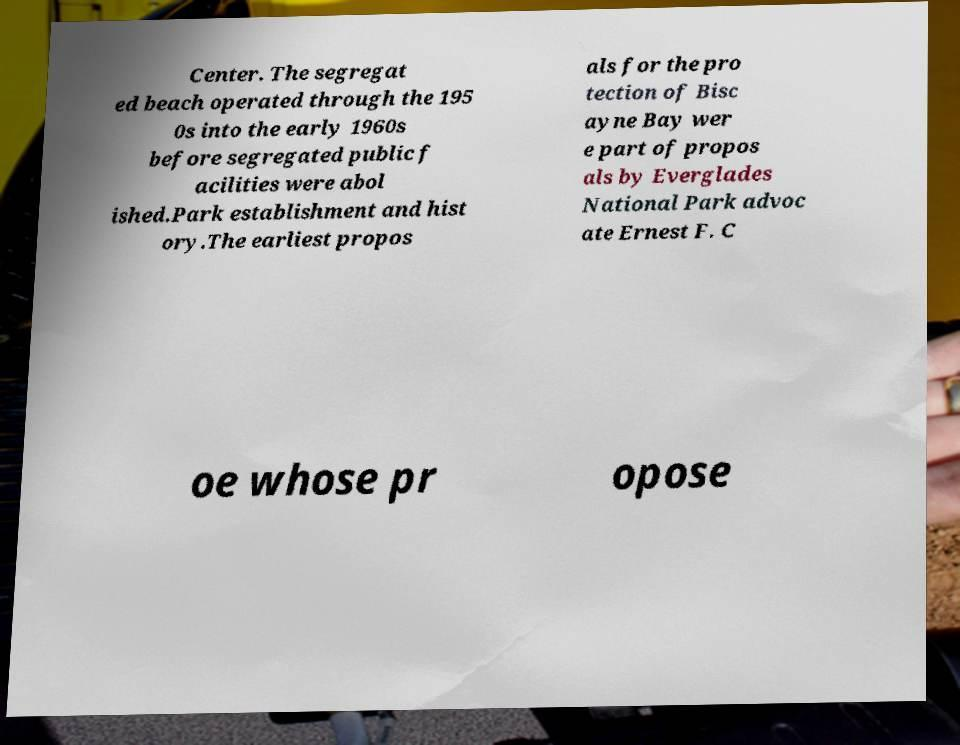Please read and relay the text visible in this image. What does it say? Center. The segregat ed beach operated through the 195 0s into the early 1960s before segregated public f acilities were abol ished.Park establishment and hist ory.The earliest propos als for the pro tection of Bisc ayne Bay wer e part of propos als by Everglades National Park advoc ate Ernest F. C oe whose pr opose 